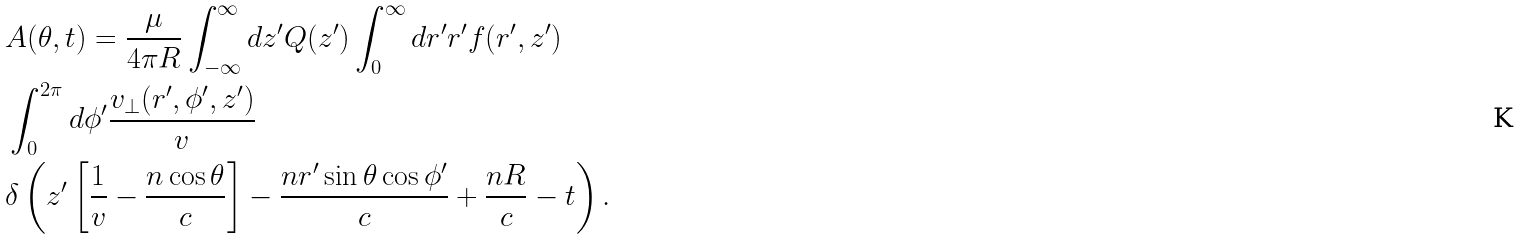Convert formula to latex. <formula><loc_0><loc_0><loc_500><loc_500>& A ( \theta , t ) = \frac { \mu } { 4 \pi R } \int ^ { \infty } _ { - \infty } d z ^ { \prime } Q ( z ^ { \prime } ) \int ^ { \infty } _ { 0 } d r ^ { \prime } r ^ { \prime } f ( r ^ { \prime } , z ^ { \prime } ) \\ & \int ^ { 2 \pi } _ { 0 } d \phi ^ { \prime } \frac { v _ { \perp } ( r ^ { \prime } , \phi ^ { \prime } , z ^ { \prime } ) } { v } \\ & \delta \left ( z ^ { \prime } \left [ \frac { 1 } { v } - \frac { n \cos \theta } { c } \right ] - \frac { n r ^ { \prime } \sin \theta \cos \phi ^ { \prime } } { c } + \frac { n R } { c } - t \right ) .</formula> 